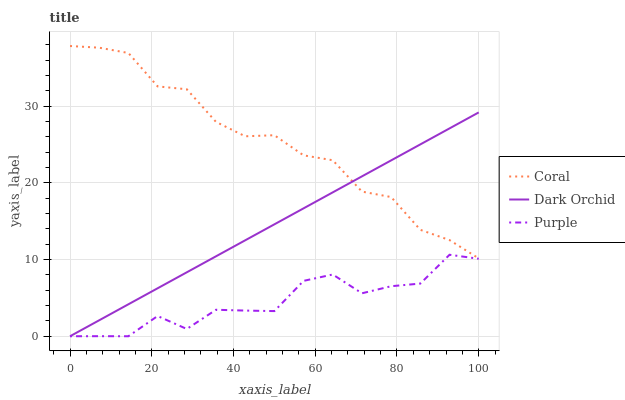Does Purple have the minimum area under the curve?
Answer yes or no. Yes. Does Coral have the maximum area under the curve?
Answer yes or no. Yes. Does Dark Orchid have the minimum area under the curve?
Answer yes or no. No. Does Dark Orchid have the maximum area under the curve?
Answer yes or no. No. Is Dark Orchid the smoothest?
Answer yes or no. Yes. Is Purple the roughest?
Answer yes or no. Yes. Is Coral the smoothest?
Answer yes or no. No. Is Coral the roughest?
Answer yes or no. No. Does Purple have the lowest value?
Answer yes or no. Yes. Does Coral have the lowest value?
Answer yes or no. No. Does Coral have the highest value?
Answer yes or no. Yes. Does Dark Orchid have the highest value?
Answer yes or no. No. Is Purple less than Coral?
Answer yes or no. Yes. Is Coral greater than Purple?
Answer yes or no. Yes. Does Purple intersect Dark Orchid?
Answer yes or no. Yes. Is Purple less than Dark Orchid?
Answer yes or no. No. Is Purple greater than Dark Orchid?
Answer yes or no. No. Does Purple intersect Coral?
Answer yes or no. No. 